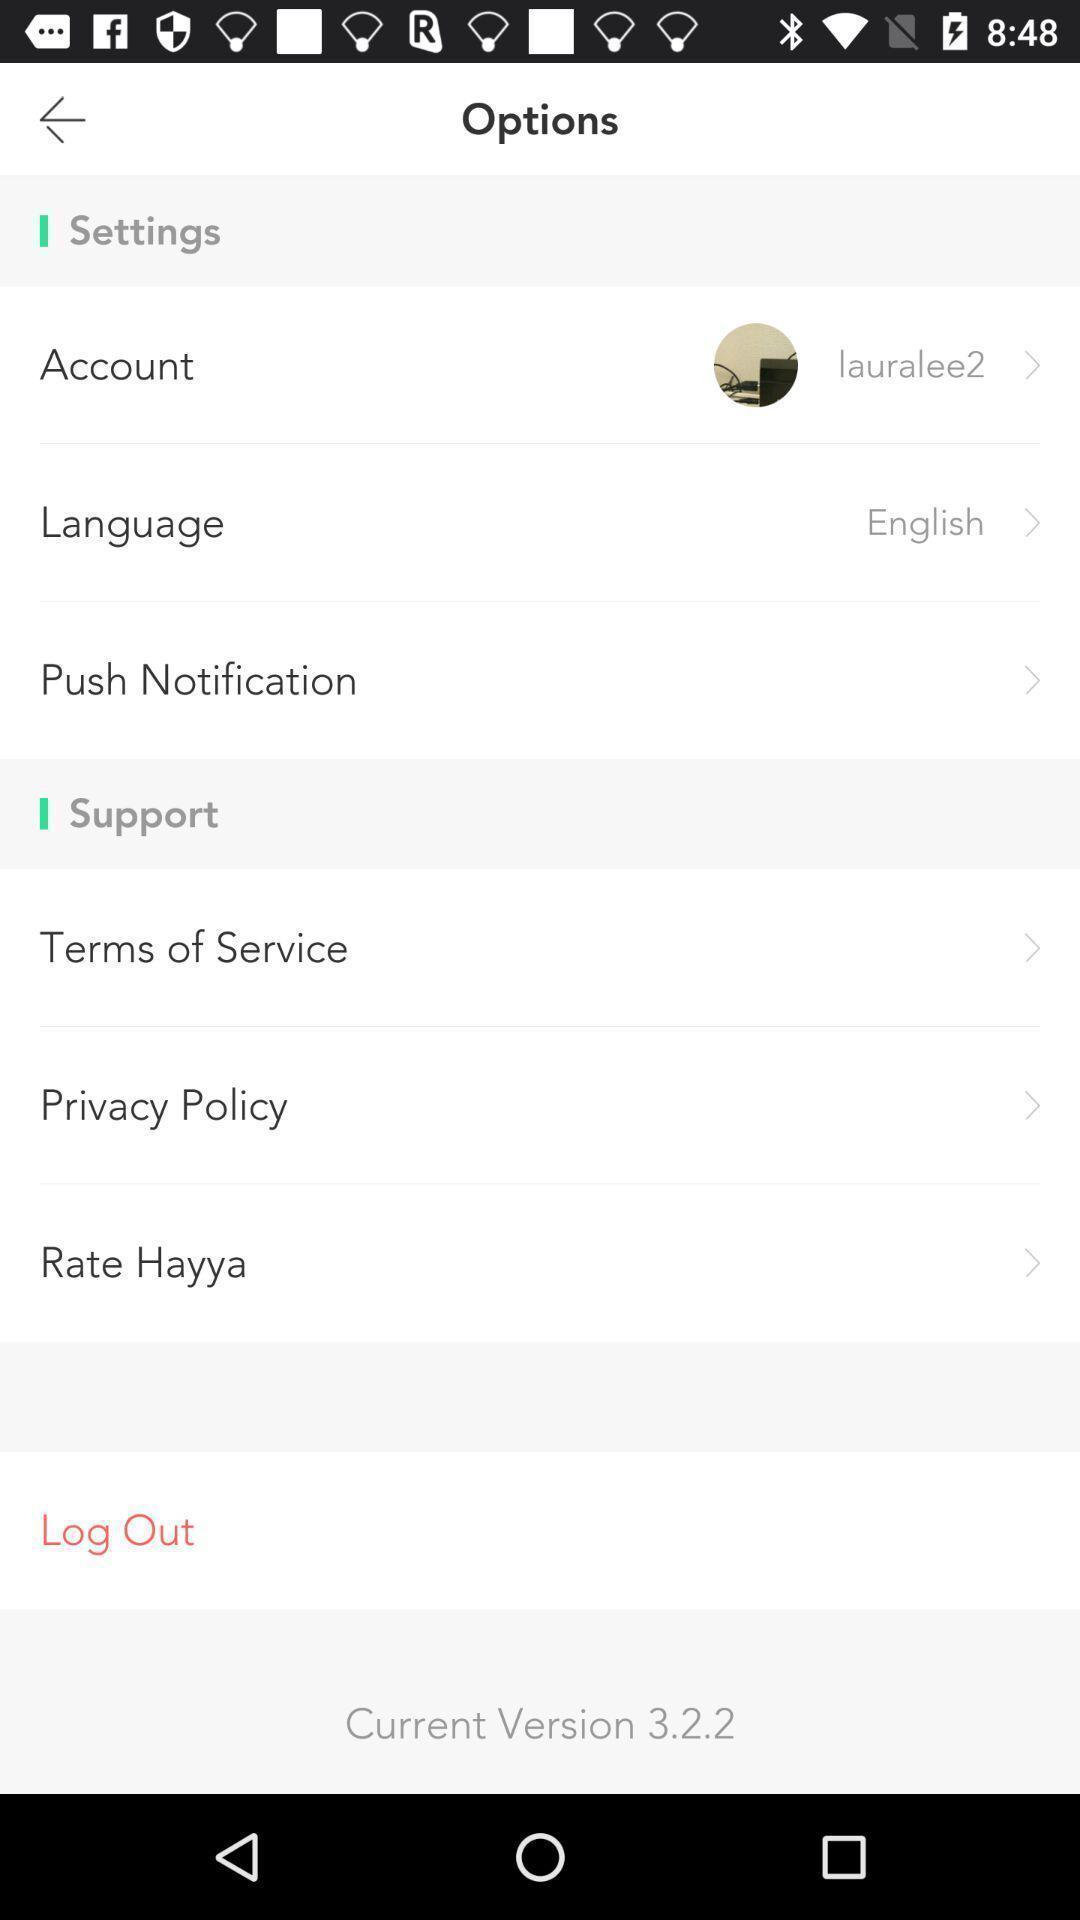What is the overall content of this screenshot? Screen shows various options. 